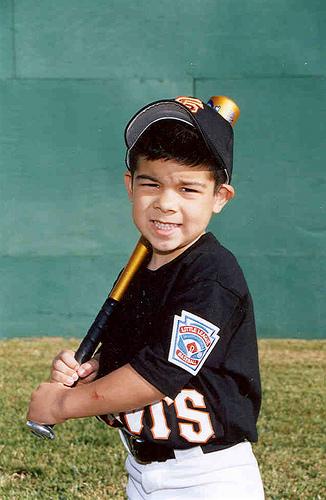What is the boy holding?
Answer briefly. Bat. Is this a male or female?
Keep it brief. Male. Is this a pro player?
Answer briefly. No. Is this Mark McGwire?
Write a very short answer. No. 